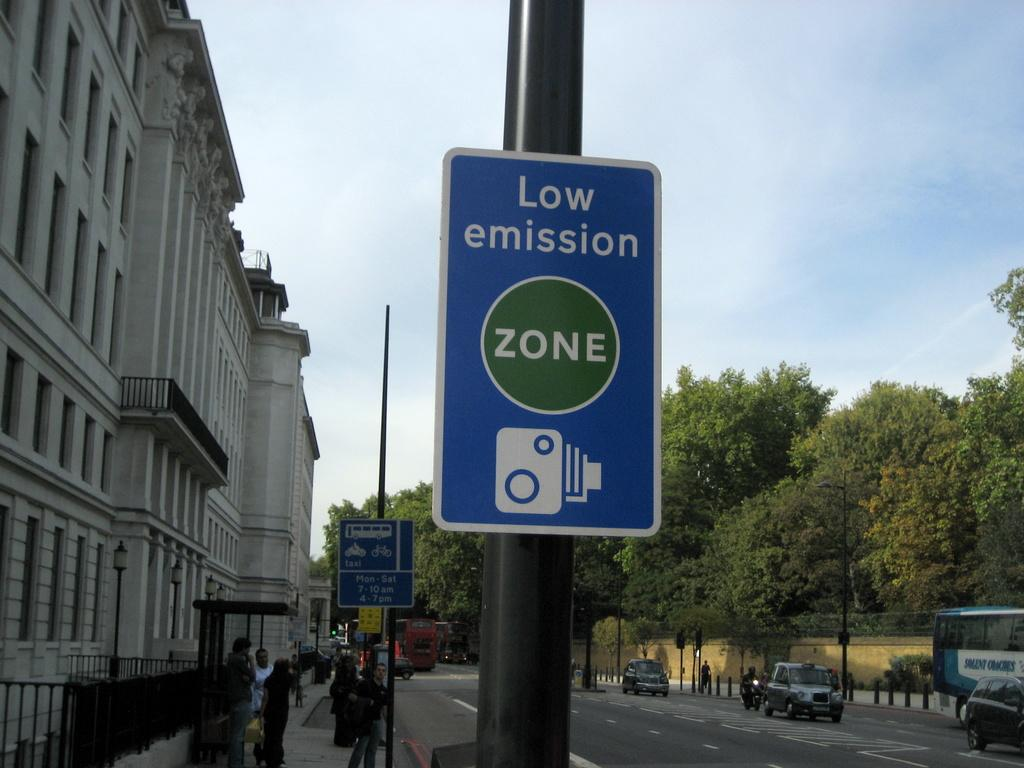<image>
Share a concise interpretation of the image provided. A street sign that informs people that the area is a low emission zone. 